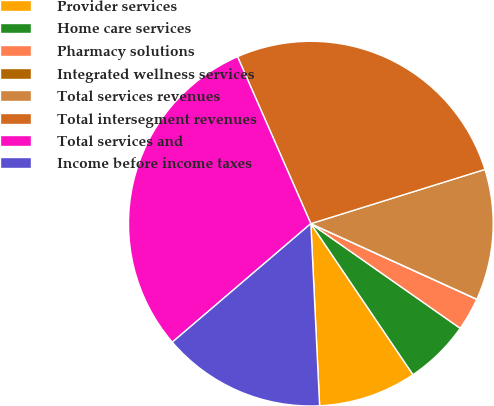Convert chart. <chart><loc_0><loc_0><loc_500><loc_500><pie_chart><fcel>Provider services<fcel>Home care services<fcel>Pharmacy solutions<fcel>Integrated wellness services<fcel>Total services revenues<fcel>Total intersegment revenues<fcel>Total services and<fcel>Income before income taxes<nl><fcel>8.7%<fcel>5.81%<fcel>2.91%<fcel>0.02%<fcel>11.6%<fcel>26.78%<fcel>29.68%<fcel>14.5%<nl></chart> 